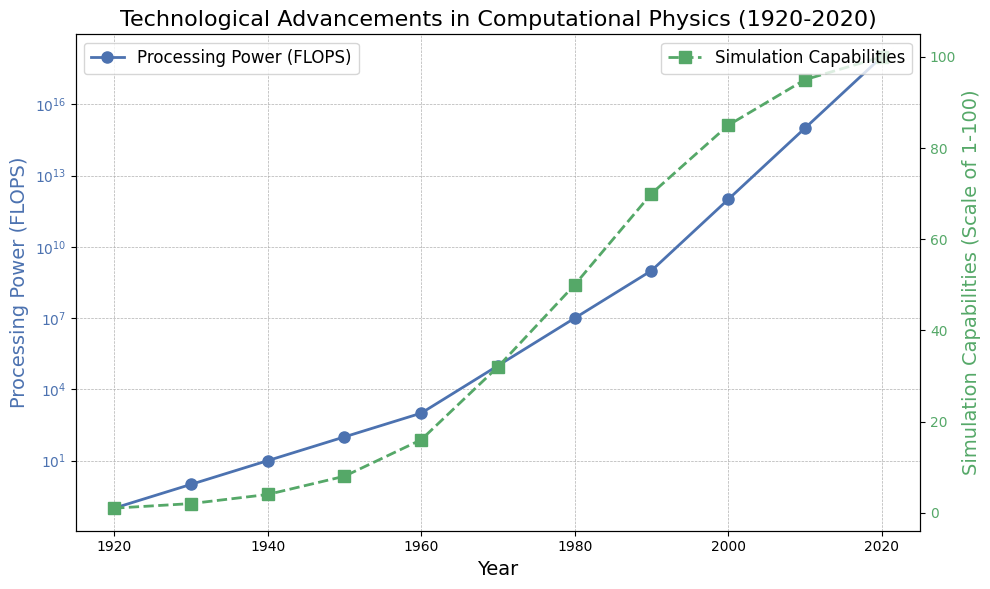What is the processing power in FLOPS for the year 1970? Locate the data point for 1970 on the x-axis and check the corresponding value on the left y-axis labeled "Processing Power (FLOPS)." The value is marked by a blue line and circle, which corresponds to 1e5 FLOPS.
Answer: 1e5 How much did the simulation capabilities increase from 1980 to 1990? Identify the simulation capabilities for 1980 and 1990 on the right y-axis labeled "Simulation Capabilities (Scale of 1-100)." They are marked by green squares. The values are 50 for 1980 and 70 for 1990. Calculate the difference: 70 - 50 = 20.
Answer: 20 Which year shows the largest jump in processing power compared to the previous decade? Look at the steepness of the blue line between decades. The largest jump occurs from 1960 to 1970, where processing power increases from 1e3 to 1e5 (a hundredfold increase).
Answer: 1970 In 2000, which is higher: the processing power or the simulation capabilities? For the year 2000, locate both the blue circle (processing power) and the green square (simulation capabilities) on the respective y-axes. Processing power is 1e12 FLOPS, and simulation capabilities are 85. Since 1e12 is much higher than 85 in scale, the processing power is higher.
Answer: Processing power What is the ratio of processing power between 2020 and 2010? Find the processing power values for 2020 (1e18 FLOPS) and 2010 (1e15 FLOPS). Calculate the ratio by dividing 1e18 by 1e15: 1e18 / 1e15 = 1000.
Answer: 1000 What is the trend of simulation capabilities from 1940 to 1960? Observe the green line between 1940 and 1960. Simulation capabilities increase steadily from 4 in 1940 to 16 in 1960, showing a fourfold increase.
Answer: Increasing What is the percentage increase in simulation capabilities from 1950 to 1960? For 1950 and 1960, simulation capabilities are 8 and 16 respectively. Calculate the percentage increase: ((16 - 8) / 8) * 100 = 100%.
Answer: 100% How does the processing power change between 1990 and 2000? Look at the blue line between 1990 and 2000. Processing power increases from 1e9 to 1e12.
Answer: Increases Do processing power and simulation capabilities both show an increasing trend over the entire period from 1920 to 2020? Observe both the blue line (processing power) and the green line (simulation capabilities) over all years. Both lines show a generally upward trend from 1920 to 2020.
Answer: Yes In which decade did the simulation capabilities reach half of their maximum scale of 100? The maximum simulation capabilities are 100. Locate the decade where it reaches half, 50, which happens in 1980, as indicated by the green square.
Answer: 1980 